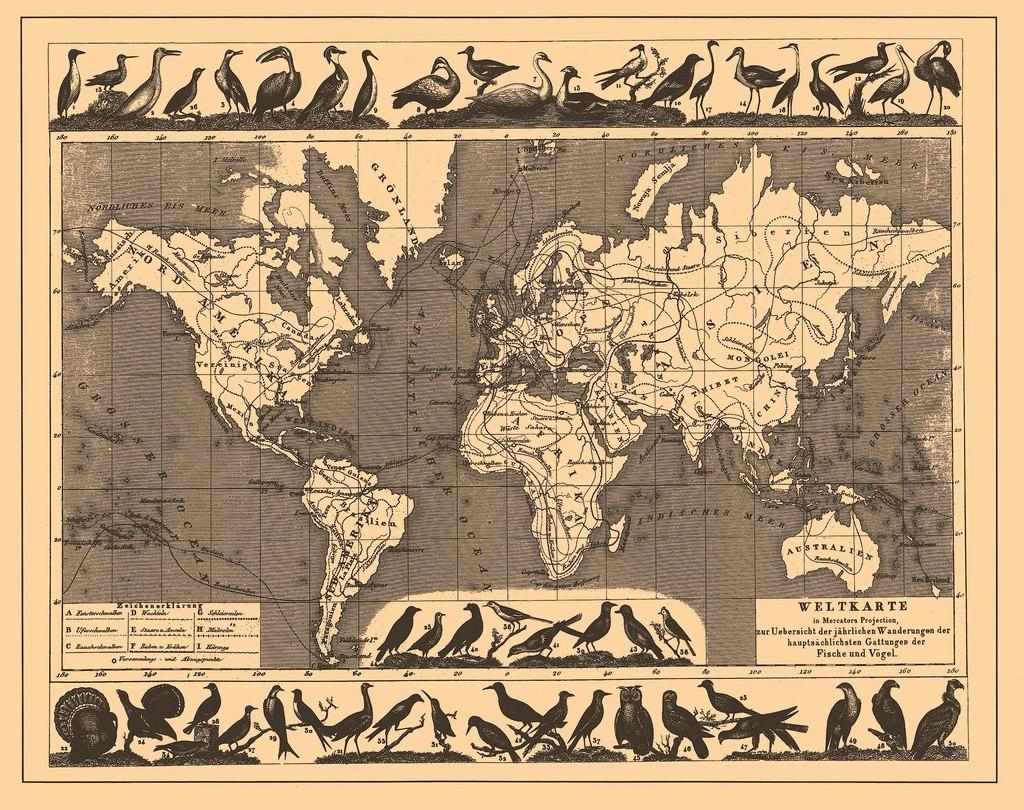<image>
Render a clear and concise summary of the photo. A map of the world is labeled "Weltkarte". 